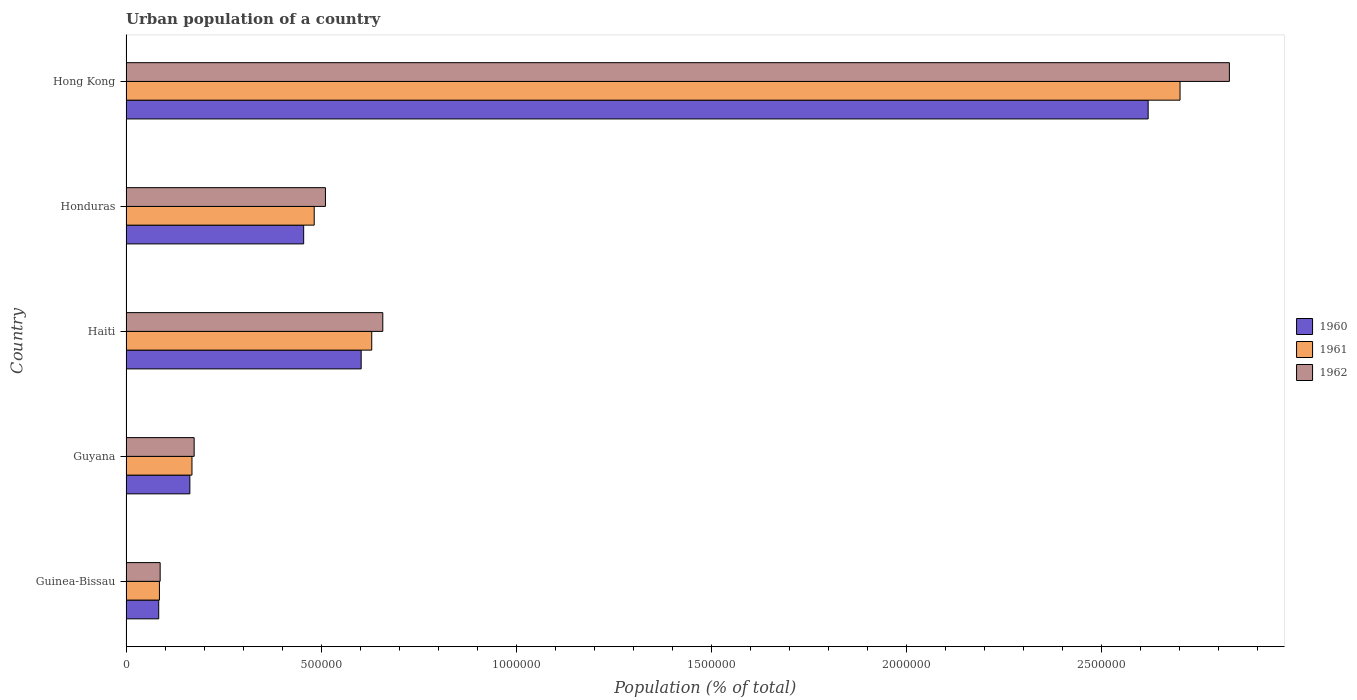How many different coloured bars are there?
Your response must be concise. 3. How many groups of bars are there?
Make the answer very short. 5. What is the label of the 2nd group of bars from the top?
Provide a succinct answer. Honduras. In how many cases, is the number of bars for a given country not equal to the number of legend labels?
Your answer should be compact. 0. What is the urban population in 1962 in Hong Kong?
Offer a very short reply. 2.83e+06. Across all countries, what is the maximum urban population in 1960?
Ensure brevity in your answer.  2.62e+06. Across all countries, what is the minimum urban population in 1962?
Provide a short and direct response. 8.75e+04. In which country was the urban population in 1961 maximum?
Provide a succinct answer. Hong Kong. In which country was the urban population in 1962 minimum?
Keep it short and to the point. Guinea-Bissau. What is the total urban population in 1962 in the graph?
Give a very brief answer. 4.26e+06. What is the difference between the urban population in 1960 in Guinea-Bissau and that in Haiti?
Offer a very short reply. -5.19e+05. What is the difference between the urban population in 1961 in Hong Kong and the urban population in 1960 in Haiti?
Provide a short and direct response. 2.10e+06. What is the average urban population in 1960 per country?
Provide a succinct answer. 7.85e+05. What is the difference between the urban population in 1962 and urban population in 1960 in Hong Kong?
Provide a short and direct response. 2.08e+05. In how many countries, is the urban population in 1962 greater than 1200000 %?
Your answer should be very brief. 1. What is the ratio of the urban population in 1962 in Guinea-Bissau to that in Haiti?
Make the answer very short. 0.13. What is the difference between the highest and the second highest urban population in 1960?
Make the answer very short. 2.02e+06. What is the difference between the highest and the lowest urban population in 1960?
Your response must be concise. 2.54e+06. In how many countries, is the urban population in 1961 greater than the average urban population in 1961 taken over all countries?
Provide a short and direct response. 1. What does the 1st bar from the top in Haiti represents?
Offer a very short reply. 1962. Is it the case that in every country, the sum of the urban population in 1961 and urban population in 1960 is greater than the urban population in 1962?
Offer a terse response. Yes. How many bars are there?
Make the answer very short. 15. What is the difference between two consecutive major ticks on the X-axis?
Provide a succinct answer. 5.00e+05. Are the values on the major ticks of X-axis written in scientific E-notation?
Your answer should be compact. No. Does the graph contain any zero values?
Keep it short and to the point. No. What is the title of the graph?
Offer a very short reply. Urban population of a country. Does "1986" appear as one of the legend labels in the graph?
Offer a terse response. No. What is the label or title of the X-axis?
Offer a terse response. Population (% of total). What is the label or title of the Y-axis?
Provide a succinct answer. Country. What is the Population (% of total) in 1960 in Guinea-Bissau?
Your answer should be compact. 8.38e+04. What is the Population (% of total) in 1961 in Guinea-Bissau?
Offer a very short reply. 8.57e+04. What is the Population (% of total) of 1962 in Guinea-Bissau?
Offer a terse response. 8.75e+04. What is the Population (% of total) of 1960 in Guyana?
Your answer should be compact. 1.64e+05. What is the Population (% of total) of 1961 in Guyana?
Give a very brief answer. 1.69e+05. What is the Population (% of total) in 1962 in Guyana?
Make the answer very short. 1.75e+05. What is the Population (% of total) in 1960 in Haiti?
Your response must be concise. 6.03e+05. What is the Population (% of total) of 1961 in Haiti?
Keep it short and to the point. 6.30e+05. What is the Population (% of total) of 1962 in Haiti?
Offer a very short reply. 6.58e+05. What is the Population (% of total) in 1960 in Honduras?
Your response must be concise. 4.55e+05. What is the Population (% of total) of 1961 in Honduras?
Provide a short and direct response. 4.82e+05. What is the Population (% of total) of 1962 in Honduras?
Provide a short and direct response. 5.11e+05. What is the Population (% of total) in 1960 in Hong Kong?
Your answer should be compact. 2.62e+06. What is the Population (% of total) in 1961 in Hong Kong?
Your answer should be compact. 2.70e+06. What is the Population (% of total) of 1962 in Hong Kong?
Give a very brief answer. 2.83e+06. Across all countries, what is the maximum Population (% of total) of 1960?
Give a very brief answer. 2.62e+06. Across all countries, what is the maximum Population (% of total) in 1961?
Your response must be concise. 2.70e+06. Across all countries, what is the maximum Population (% of total) in 1962?
Your answer should be very brief. 2.83e+06. Across all countries, what is the minimum Population (% of total) in 1960?
Your answer should be very brief. 8.38e+04. Across all countries, what is the minimum Population (% of total) of 1961?
Keep it short and to the point. 8.57e+04. Across all countries, what is the minimum Population (% of total) of 1962?
Your answer should be compact. 8.75e+04. What is the total Population (% of total) of 1960 in the graph?
Your response must be concise. 3.93e+06. What is the total Population (% of total) of 1961 in the graph?
Offer a very short reply. 4.07e+06. What is the total Population (% of total) in 1962 in the graph?
Keep it short and to the point. 4.26e+06. What is the difference between the Population (% of total) of 1960 in Guinea-Bissau and that in Guyana?
Make the answer very short. -7.98e+04. What is the difference between the Population (% of total) of 1961 in Guinea-Bissau and that in Guyana?
Provide a short and direct response. -8.34e+04. What is the difference between the Population (% of total) in 1962 in Guinea-Bissau and that in Guyana?
Keep it short and to the point. -8.72e+04. What is the difference between the Population (% of total) in 1960 in Guinea-Bissau and that in Haiti?
Make the answer very short. -5.19e+05. What is the difference between the Population (% of total) of 1961 in Guinea-Bissau and that in Haiti?
Your answer should be compact. -5.44e+05. What is the difference between the Population (% of total) of 1962 in Guinea-Bissau and that in Haiti?
Offer a very short reply. -5.71e+05. What is the difference between the Population (% of total) of 1960 in Guinea-Bissau and that in Honduras?
Give a very brief answer. -3.72e+05. What is the difference between the Population (% of total) of 1961 in Guinea-Bissau and that in Honduras?
Offer a terse response. -3.97e+05. What is the difference between the Population (% of total) of 1962 in Guinea-Bissau and that in Honduras?
Keep it short and to the point. -4.24e+05. What is the difference between the Population (% of total) of 1960 in Guinea-Bissau and that in Hong Kong?
Provide a short and direct response. -2.54e+06. What is the difference between the Population (% of total) in 1961 in Guinea-Bissau and that in Hong Kong?
Your response must be concise. -2.62e+06. What is the difference between the Population (% of total) in 1962 in Guinea-Bissau and that in Hong Kong?
Your answer should be compact. -2.74e+06. What is the difference between the Population (% of total) of 1960 in Guyana and that in Haiti?
Make the answer very short. -4.39e+05. What is the difference between the Population (% of total) in 1961 in Guyana and that in Haiti?
Keep it short and to the point. -4.61e+05. What is the difference between the Population (% of total) of 1962 in Guyana and that in Haiti?
Keep it short and to the point. -4.84e+05. What is the difference between the Population (% of total) of 1960 in Guyana and that in Honduras?
Make the answer very short. -2.92e+05. What is the difference between the Population (% of total) of 1961 in Guyana and that in Honduras?
Your answer should be compact. -3.13e+05. What is the difference between the Population (% of total) in 1962 in Guyana and that in Honduras?
Your response must be concise. -3.37e+05. What is the difference between the Population (% of total) of 1960 in Guyana and that in Hong Kong?
Offer a terse response. -2.46e+06. What is the difference between the Population (% of total) in 1961 in Guyana and that in Hong Kong?
Give a very brief answer. -2.53e+06. What is the difference between the Population (% of total) in 1962 in Guyana and that in Hong Kong?
Offer a very short reply. -2.65e+06. What is the difference between the Population (% of total) of 1960 in Haiti and that in Honduras?
Ensure brevity in your answer.  1.47e+05. What is the difference between the Population (% of total) of 1961 in Haiti and that in Honduras?
Offer a very short reply. 1.47e+05. What is the difference between the Population (% of total) in 1962 in Haiti and that in Honduras?
Provide a short and direct response. 1.47e+05. What is the difference between the Population (% of total) of 1960 in Haiti and that in Hong Kong?
Give a very brief answer. -2.02e+06. What is the difference between the Population (% of total) in 1961 in Haiti and that in Hong Kong?
Keep it short and to the point. -2.07e+06. What is the difference between the Population (% of total) in 1962 in Haiti and that in Hong Kong?
Offer a terse response. -2.17e+06. What is the difference between the Population (% of total) of 1960 in Honduras and that in Hong Kong?
Provide a succinct answer. -2.16e+06. What is the difference between the Population (% of total) of 1961 in Honduras and that in Hong Kong?
Your answer should be very brief. -2.22e+06. What is the difference between the Population (% of total) in 1962 in Honduras and that in Hong Kong?
Ensure brevity in your answer.  -2.32e+06. What is the difference between the Population (% of total) of 1960 in Guinea-Bissau and the Population (% of total) of 1961 in Guyana?
Ensure brevity in your answer.  -8.52e+04. What is the difference between the Population (% of total) in 1960 in Guinea-Bissau and the Population (% of total) in 1962 in Guyana?
Offer a terse response. -9.09e+04. What is the difference between the Population (% of total) of 1961 in Guinea-Bissau and the Population (% of total) of 1962 in Guyana?
Ensure brevity in your answer.  -8.90e+04. What is the difference between the Population (% of total) of 1960 in Guinea-Bissau and the Population (% of total) of 1961 in Haiti?
Ensure brevity in your answer.  -5.46e+05. What is the difference between the Population (% of total) of 1960 in Guinea-Bissau and the Population (% of total) of 1962 in Haiti?
Your answer should be very brief. -5.74e+05. What is the difference between the Population (% of total) of 1961 in Guinea-Bissau and the Population (% of total) of 1962 in Haiti?
Offer a terse response. -5.73e+05. What is the difference between the Population (% of total) in 1960 in Guinea-Bissau and the Population (% of total) in 1961 in Honduras?
Give a very brief answer. -3.99e+05. What is the difference between the Population (% of total) in 1960 in Guinea-Bissau and the Population (% of total) in 1962 in Honduras?
Keep it short and to the point. -4.27e+05. What is the difference between the Population (% of total) in 1961 in Guinea-Bissau and the Population (% of total) in 1962 in Honduras?
Keep it short and to the point. -4.26e+05. What is the difference between the Population (% of total) in 1960 in Guinea-Bissau and the Population (% of total) in 1961 in Hong Kong?
Make the answer very short. -2.62e+06. What is the difference between the Population (% of total) of 1960 in Guinea-Bissau and the Population (% of total) of 1962 in Hong Kong?
Ensure brevity in your answer.  -2.74e+06. What is the difference between the Population (% of total) of 1961 in Guinea-Bissau and the Population (% of total) of 1962 in Hong Kong?
Offer a very short reply. -2.74e+06. What is the difference between the Population (% of total) in 1960 in Guyana and the Population (% of total) in 1961 in Haiti?
Your answer should be very brief. -4.66e+05. What is the difference between the Population (% of total) in 1960 in Guyana and the Population (% of total) in 1962 in Haiti?
Provide a short and direct response. -4.95e+05. What is the difference between the Population (% of total) in 1961 in Guyana and the Population (% of total) in 1962 in Haiti?
Offer a terse response. -4.89e+05. What is the difference between the Population (% of total) of 1960 in Guyana and the Population (% of total) of 1961 in Honduras?
Provide a short and direct response. -3.19e+05. What is the difference between the Population (% of total) in 1960 in Guyana and the Population (% of total) in 1962 in Honduras?
Offer a very short reply. -3.48e+05. What is the difference between the Population (% of total) of 1961 in Guyana and the Population (% of total) of 1962 in Honduras?
Offer a very short reply. -3.42e+05. What is the difference between the Population (% of total) in 1960 in Guyana and the Population (% of total) in 1961 in Hong Kong?
Make the answer very short. -2.54e+06. What is the difference between the Population (% of total) in 1960 in Guyana and the Population (% of total) in 1962 in Hong Kong?
Offer a terse response. -2.66e+06. What is the difference between the Population (% of total) in 1961 in Guyana and the Population (% of total) in 1962 in Hong Kong?
Ensure brevity in your answer.  -2.66e+06. What is the difference between the Population (% of total) in 1960 in Haiti and the Population (% of total) in 1961 in Honduras?
Keep it short and to the point. 1.20e+05. What is the difference between the Population (% of total) of 1960 in Haiti and the Population (% of total) of 1962 in Honduras?
Keep it short and to the point. 9.16e+04. What is the difference between the Population (% of total) of 1961 in Haiti and the Population (% of total) of 1962 in Honduras?
Your answer should be compact. 1.19e+05. What is the difference between the Population (% of total) of 1960 in Haiti and the Population (% of total) of 1961 in Hong Kong?
Make the answer very short. -2.10e+06. What is the difference between the Population (% of total) of 1960 in Haiti and the Population (% of total) of 1962 in Hong Kong?
Your answer should be compact. -2.23e+06. What is the difference between the Population (% of total) of 1961 in Haiti and the Population (% of total) of 1962 in Hong Kong?
Offer a very short reply. -2.20e+06. What is the difference between the Population (% of total) of 1960 in Honduras and the Population (% of total) of 1961 in Hong Kong?
Provide a short and direct response. -2.25e+06. What is the difference between the Population (% of total) of 1960 in Honduras and the Population (% of total) of 1962 in Hong Kong?
Offer a terse response. -2.37e+06. What is the difference between the Population (% of total) of 1961 in Honduras and the Population (% of total) of 1962 in Hong Kong?
Provide a succinct answer. -2.35e+06. What is the average Population (% of total) in 1960 per country?
Offer a very short reply. 7.85e+05. What is the average Population (% of total) in 1961 per country?
Offer a terse response. 8.14e+05. What is the average Population (% of total) of 1962 per country?
Make the answer very short. 8.52e+05. What is the difference between the Population (% of total) in 1960 and Population (% of total) in 1961 in Guinea-Bissau?
Offer a very short reply. -1870. What is the difference between the Population (% of total) of 1960 and Population (% of total) of 1962 in Guinea-Bissau?
Give a very brief answer. -3704. What is the difference between the Population (% of total) in 1961 and Population (% of total) in 1962 in Guinea-Bissau?
Keep it short and to the point. -1834. What is the difference between the Population (% of total) of 1960 and Population (% of total) of 1961 in Guyana?
Give a very brief answer. -5400. What is the difference between the Population (% of total) in 1960 and Population (% of total) in 1962 in Guyana?
Keep it short and to the point. -1.10e+04. What is the difference between the Population (% of total) in 1961 and Population (% of total) in 1962 in Guyana?
Make the answer very short. -5622. What is the difference between the Population (% of total) of 1960 and Population (% of total) of 1961 in Haiti?
Make the answer very short. -2.71e+04. What is the difference between the Population (% of total) in 1960 and Population (% of total) in 1962 in Haiti?
Make the answer very short. -5.54e+04. What is the difference between the Population (% of total) in 1961 and Population (% of total) in 1962 in Haiti?
Your answer should be very brief. -2.83e+04. What is the difference between the Population (% of total) in 1960 and Population (% of total) in 1961 in Honduras?
Give a very brief answer. -2.70e+04. What is the difference between the Population (% of total) in 1960 and Population (% of total) in 1962 in Honduras?
Your answer should be very brief. -5.58e+04. What is the difference between the Population (% of total) of 1961 and Population (% of total) of 1962 in Honduras?
Give a very brief answer. -2.88e+04. What is the difference between the Population (% of total) of 1960 and Population (% of total) of 1961 in Hong Kong?
Your response must be concise. -8.18e+04. What is the difference between the Population (% of total) in 1960 and Population (% of total) in 1962 in Hong Kong?
Your response must be concise. -2.08e+05. What is the difference between the Population (% of total) in 1961 and Population (% of total) in 1962 in Hong Kong?
Your response must be concise. -1.26e+05. What is the ratio of the Population (% of total) of 1960 in Guinea-Bissau to that in Guyana?
Ensure brevity in your answer.  0.51. What is the ratio of the Population (% of total) of 1961 in Guinea-Bissau to that in Guyana?
Your answer should be compact. 0.51. What is the ratio of the Population (% of total) of 1962 in Guinea-Bissau to that in Guyana?
Keep it short and to the point. 0.5. What is the ratio of the Population (% of total) of 1960 in Guinea-Bissau to that in Haiti?
Offer a terse response. 0.14. What is the ratio of the Population (% of total) of 1961 in Guinea-Bissau to that in Haiti?
Offer a terse response. 0.14. What is the ratio of the Population (% of total) of 1962 in Guinea-Bissau to that in Haiti?
Offer a very short reply. 0.13. What is the ratio of the Population (% of total) in 1960 in Guinea-Bissau to that in Honduras?
Offer a terse response. 0.18. What is the ratio of the Population (% of total) of 1961 in Guinea-Bissau to that in Honduras?
Make the answer very short. 0.18. What is the ratio of the Population (% of total) of 1962 in Guinea-Bissau to that in Honduras?
Make the answer very short. 0.17. What is the ratio of the Population (% of total) in 1960 in Guinea-Bissau to that in Hong Kong?
Your response must be concise. 0.03. What is the ratio of the Population (% of total) of 1961 in Guinea-Bissau to that in Hong Kong?
Your answer should be very brief. 0.03. What is the ratio of the Population (% of total) in 1962 in Guinea-Bissau to that in Hong Kong?
Keep it short and to the point. 0.03. What is the ratio of the Population (% of total) in 1960 in Guyana to that in Haiti?
Offer a terse response. 0.27. What is the ratio of the Population (% of total) of 1961 in Guyana to that in Haiti?
Keep it short and to the point. 0.27. What is the ratio of the Population (% of total) in 1962 in Guyana to that in Haiti?
Offer a very short reply. 0.27. What is the ratio of the Population (% of total) of 1960 in Guyana to that in Honduras?
Offer a very short reply. 0.36. What is the ratio of the Population (% of total) in 1961 in Guyana to that in Honduras?
Ensure brevity in your answer.  0.35. What is the ratio of the Population (% of total) of 1962 in Guyana to that in Honduras?
Your response must be concise. 0.34. What is the ratio of the Population (% of total) in 1960 in Guyana to that in Hong Kong?
Offer a terse response. 0.06. What is the ratio of the Population (% of total) in 1961 in Guyana to that in Hong Kong?
Your answer should be compact. 0.06. What is the ratio of the Population (% of total) of 1962 in Guyana to that in Hong Kong?
Offer a very short reply. 0.06. What is the ratio of the Population (% of total) in 1960 in Haiti to that in Honduras?
Your answer should be compact. 1.32. What is the ratio of the Population (% of total) of 1961 in Haiti to that in Honduras?
Ensure brevity in your answer.  1.31. What is the ratio of the Population (% of total) in 1962 in Haiti to that in Honduras?
Your answer should be very brief. 1.29. What is the ratio of the Population (% of total) in 1960 in Haiti to that in Hong Kong?
Give a very brief answer. 0.23. What is the ratio of the Population (% of total) in 1961 in Haiti to that in Hong Kong?
Your answer should be compact. 0.23. What is the ratio of the Population (% of total) of 1962 in Haiti to that in Hong Kong?
Provide a succinct answer. 0.23. What is the ratio of the Population (% of total) in 1960 in Honduras to that in Hong Kong?
Give a very brief answer. 0.17. What is the ratio of the Population (% of total) of 1961 in Honduras to that in Hong Kong?
Provide a short and direct response. 0.18. What is the ratio of the Population (% of total) of 1962 in Honduras to that in Hong Kong?
Offer a very short reply. 0.18. What is the difference between the highest and the second highest Population (% of total) of 1960?
Keep it short and to the point. 2.02e+06. What is the difference between the highest and the second highest Population (% of total) of 1961?
Provide a short and direct response. 2.07e+06. What is the difference between the highest and the second highest Population (% of total) in 1962?
Offer a terse response. 2.17e+06. What is the difference between the highest and the lowest Population (% of total) of 1960?
Ensure brevity in your answer.  2.54e+06. What is the difference between the highest and the lowest Population (% of total) of 1961?
Give a very brief answer. 2.62e+06. What is the difference between the highest and the lowest Population (% of total) of 1962?
Your response must be concise. 2.74e+06. 